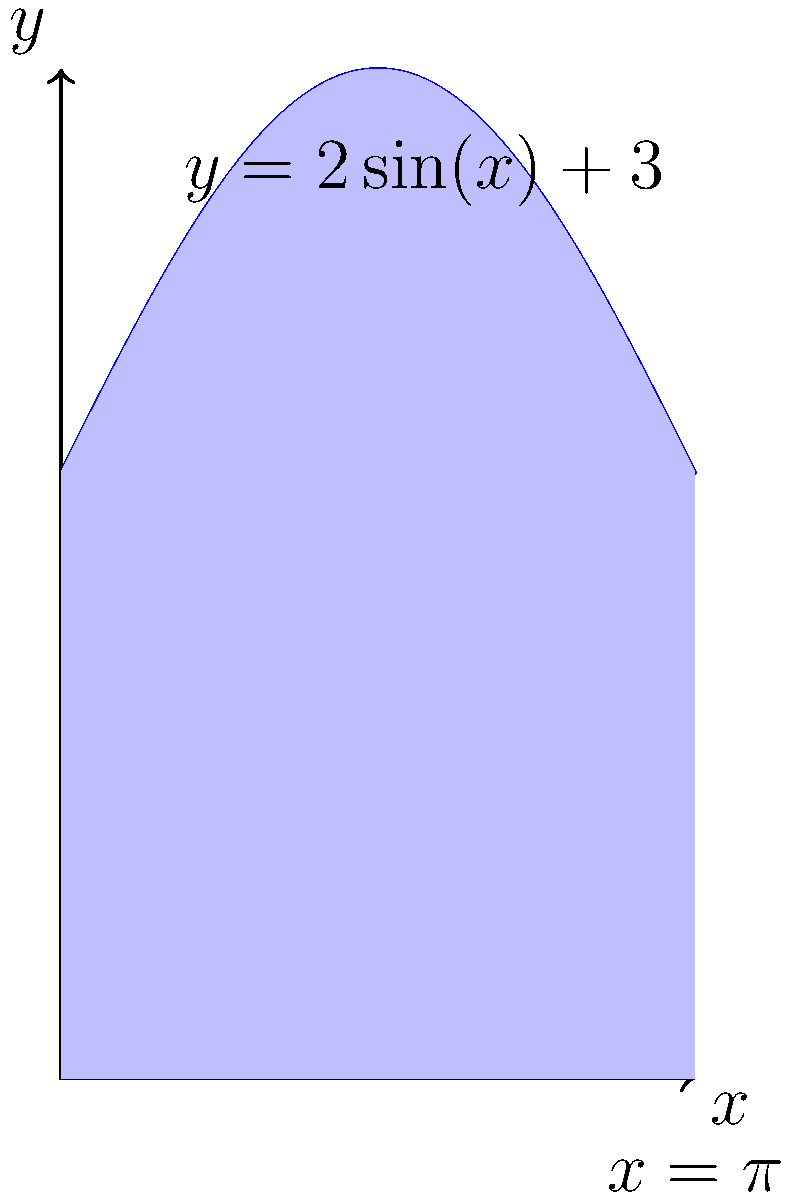You're tasked with estimating the area of an irregularly shaped construction site. The site's boundary can be approximated by the function $y = 2\sin(x) + 3$ from $x = 0$ to $x = \pi$. Without using proper integration techniques (too time-consuming), estimate the area by dividing the region into 3 equal parts and using the midpoint rule. Round your answer to the nearest whole number. Let's approach this step-by-step:

1) The interval $[0, \pi]$ needs to be divided into 3 equal parts. Each subinterval will have a width of $\Delta x = \frac{\pi}{3}$.

2) The midpoints of these subintervals are:
   $x_1 = \frac{\pi}{6}$, $x_2 = \frac{\pi}{2}$, $x_3 = \frac{5\pi}{6}$

3) Calculate $f(x)$ at each midpoint:
   $f(\frac{\pi}{6}) = 2\sin(\frac{\pi}{6}) + 3 = 2(0.5) + 3 = 4$
   $f(\frac{\pi}{2}) = 2\sin(\frac{\pi}{2}) + 3 = 2(1) + 3 = 5$
   $f(\frac{5\pi}{6}) = 2\sin(\frac{5\pi}{6}) + 3 = 2(0.5) + 3 = 4$

4) The estimated area using the midpoint rule is:
   $A \approx \Delta x [f(x_1) + f(x_2) + f(x_3)]$
   $A \approx \frac{\pi}{3} [4 + 5 + 4]$
   $A \approx \frac{\pi}{3} (13)$
   $A \approx 13.6$

5) Rounding to the nearest whole number: 14
Answer: 14 square units 